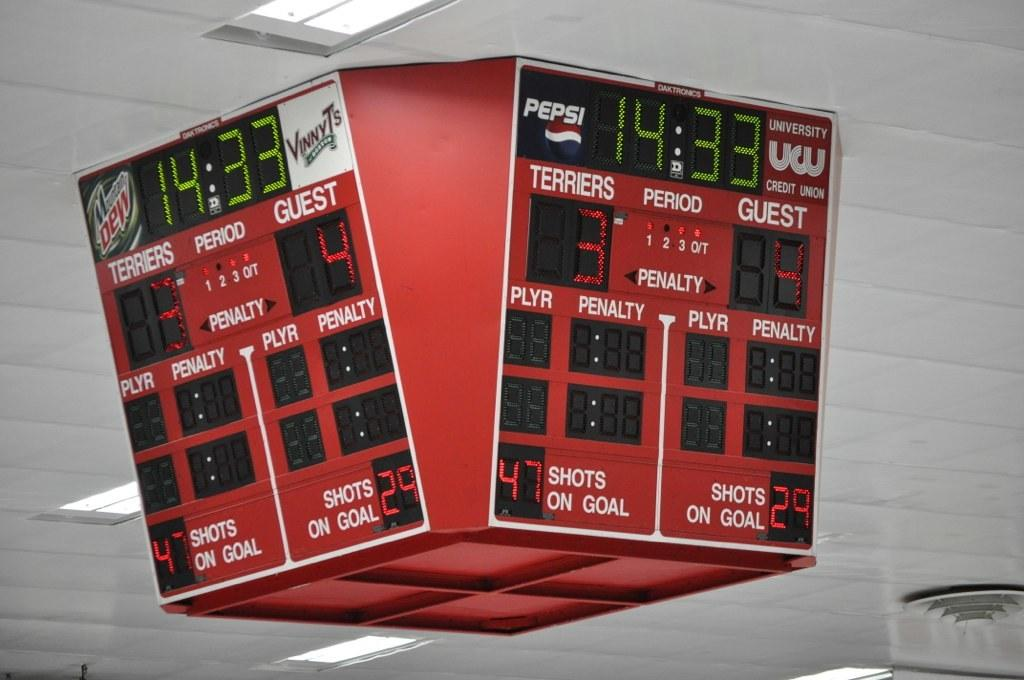<image>
Offer a succinct explanation of the picture presented. A scoreboard shows the score is Terriers 3, Guest 4. 